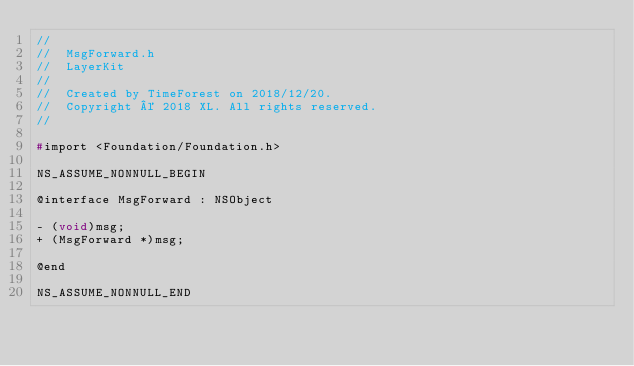<code> <loc_0><loc_0><loc_500><loc_500><_C_>//
//  MsgForward.h
//  LayerKit
//
//  Created by TimeForest on 2018/12/20.
//  Copyright © 2018 XL. All rights reserved.
//

#import <Foundation/Foundation.h>

NS_ASSUME_NONNULL_BEGIN

@interface MsgForward : NSObject

- (void)msg;
+ (MsgForward *)msg;

@end

NS_ASSUME_NONNULL_END
</code> 